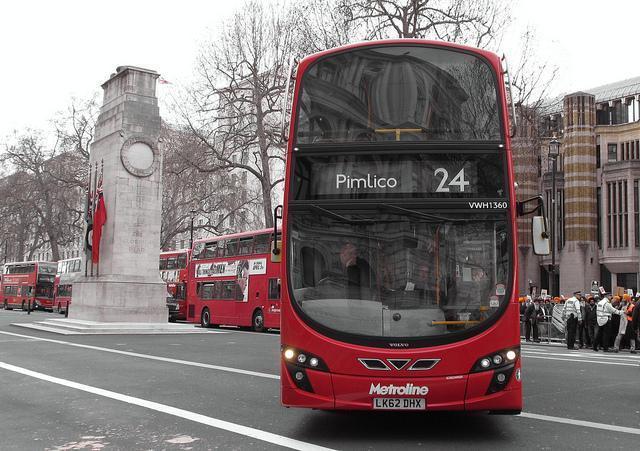How many buses are visible?
Give a very brief answer. 3. 